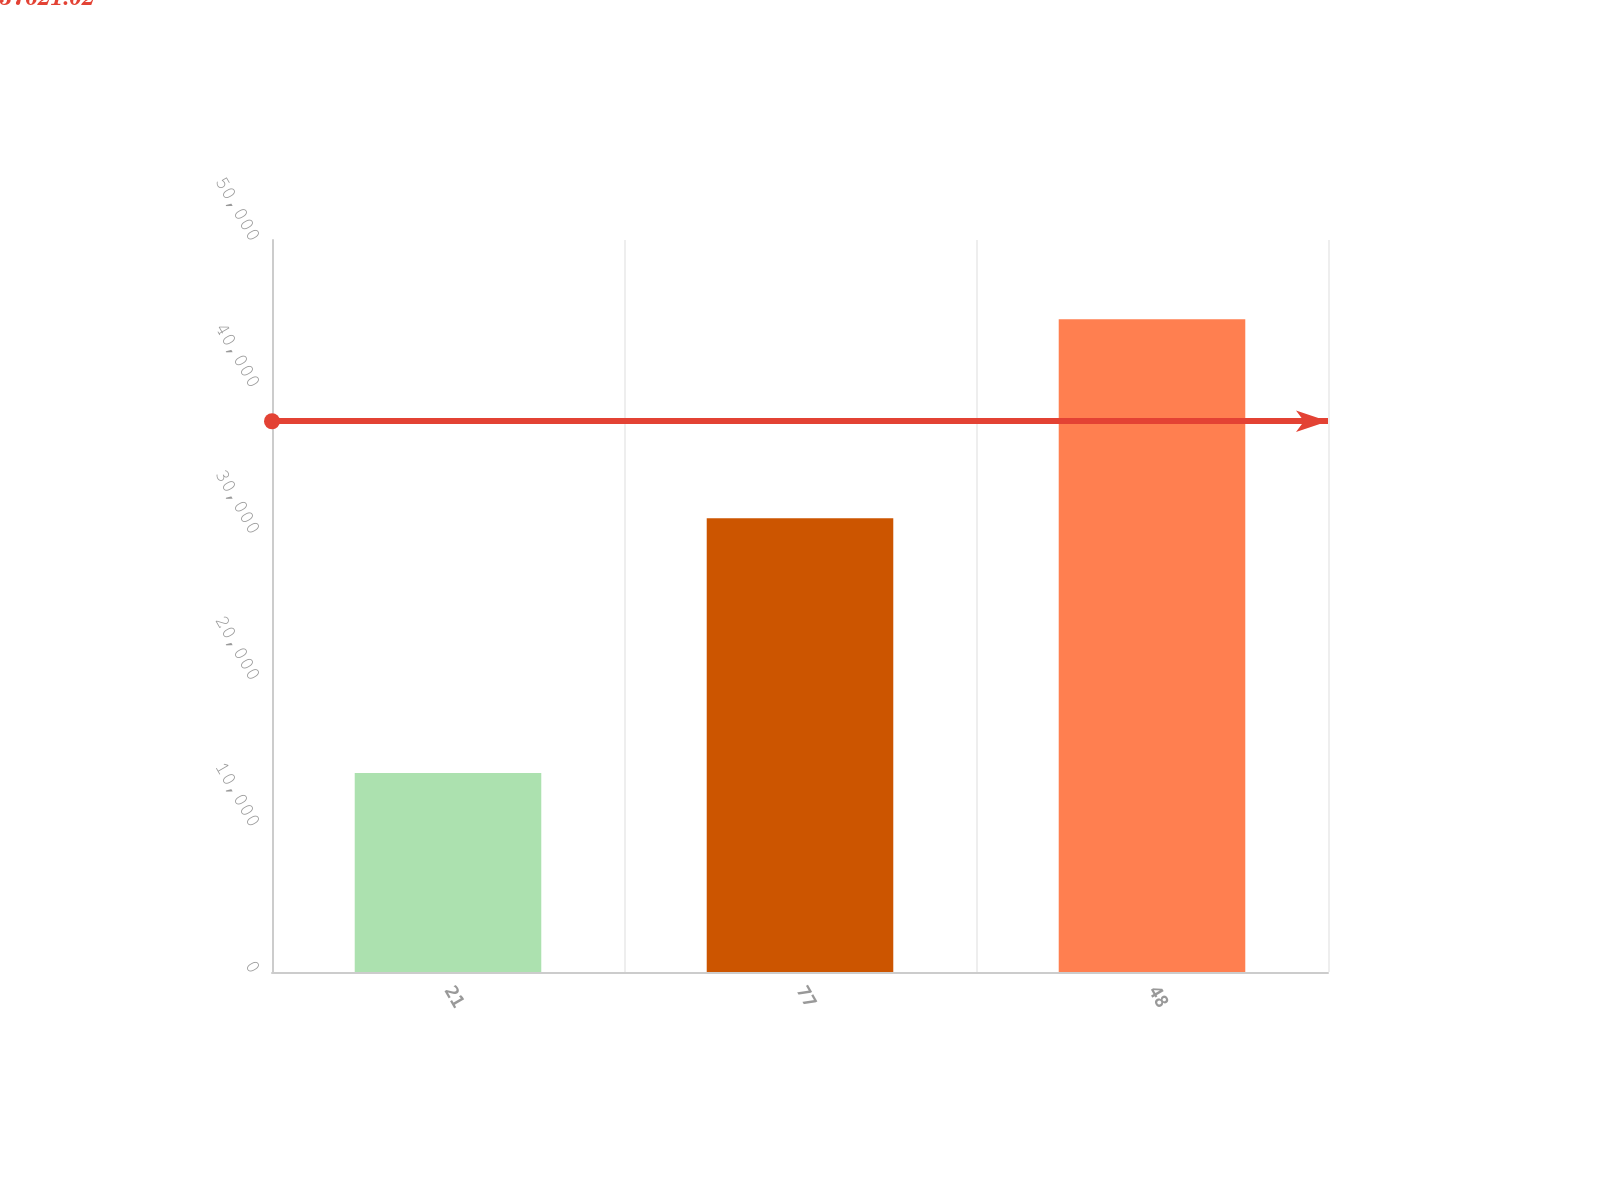Convert chart. <chart><loc_0><loc_0><loc_500><loc_500><bar_chart><fcel>21<fcel>77<fcel>48<nl><fcel>13599<fcel>30986<fcel>44585<nl></chart> 